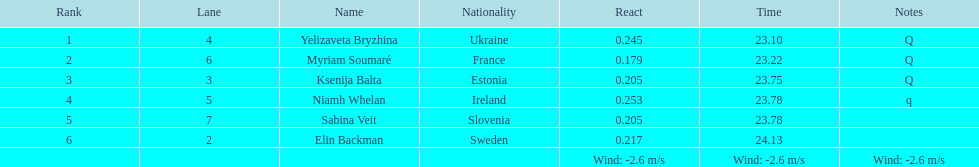Whose time goes beyond 2 Elin Backman. Parse the table in full. {'header': ['Rank', 'Lane', 'Name', 'Nationality', 'React', 'Time', 'Notes'], 'rows': [['1', '4', 'Yelizaveta Bryzhina', 'Ukraine', '0.245', '23.10', 'Q'], ['2', '6', 'Myriam Soumaré', 'France', '0.179', '23.22', 'Q'], ['3', '3', 'Ksenija Balta', 'Estonia', '0.205', '23.75', 'Q'], ['4', '5', 'Niamh Whelan', 'Ireland', '0.253', '23.78', 'q'], ['5', '7', 'Sabina Veit', 'Slovenia', '0.205', '23.78', ''], ['6', '2', 'Elin Backman', 'Sweden', '0.217', '24.13', ''], ['', '', '', '', 'Wind: -2.6\xa0m/s', 'Wind: -2.6\xa0m/s', 'Wind: -2.6\xa0m/s']]} 